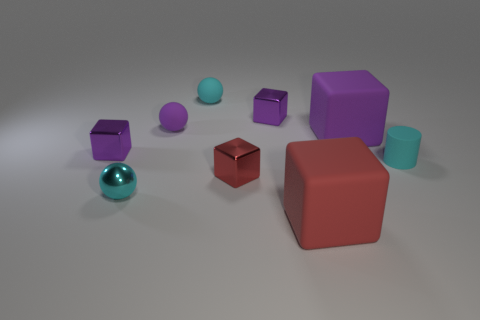Are there any objects that appear similar to each other? Yes, the two small purple cubes resemble each other not only in color but also in shape, although their sizes are slightly different. Furthermore, the large purple cube seems to be a scaled-up version of these smaller cubes.  Can you describe the textures visible in the image? Certainly, the textures in the image range from the shiny, reflective surface of the small metal sphere to the matte finish of the various cubes and the cylinder. The interplay of these textures adds depth to the scene and highlights the different material qualities of each object. 